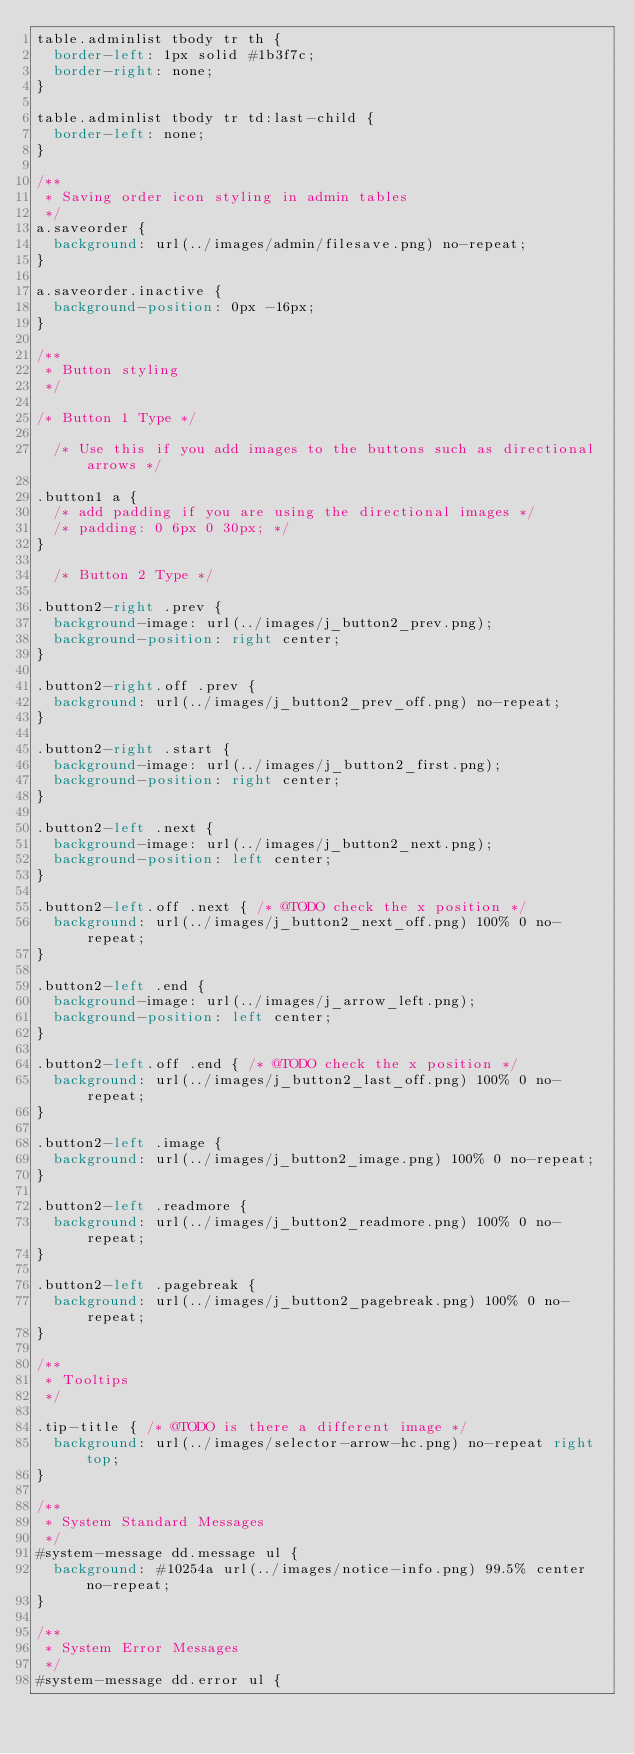Convert code to text. <code><loc_0><loc_0><loc_500><loc_500><_CSS_>table.adminlist tbody tr th {
	border-left: 1px solid #1b3f7c;
	border-right: none;
}

table.adminlist tbody tr td:last-child {
	border-left: none;
}

/**
 * Saving order icon styling in admin tables
 */
a.saveorder {
	background: url(../images/admin/filesave.png) no-repeat;
}

a.saveorder.inactive {
	background-position: 0px -16px;
}

/**
 * Button styling
 */

/* Button 1 Type */

	/* Use this if you add images to the buttons such as directional arrows */

.button1 a {
	/* add padding if you are using the directional images */
	/* padding: 0 6px 0 30px; */
}

	/* Button 2 Type */

.button2-right .prev {
	background-image: url(../images/j_button2_prev.png);
	background-position: right center;
}

.button2-right.off .prev {
	background: url(../images/j_button2_prev_off.png) no-repeat;
}

.button2-right .start {
	background-image: url(../images/j_button2_first.png);
	background-position: right center;
}

.button2-left .next {
	background-image: url(../images/j_button2_next.png);
	background-position: left center;
}

.button2-left.off .next { /* @TODO check the x position */
	background: url(../images/j_button2_next_off.png) 100% 0 no-repeat;
}

.button2-left .end {
	background-image: url(../images/j_arrow_left.png);
	background-position: left center;
}

.button2-left.off .end { /* @TODO check the x position */
	background: url(../images/j_button2_last_off.png) 100% 0 no-repeat;
}

.button2-left .image {
	background: url(../images/j_button2_image.png) 100% 0 no-repeat;
}

.button2-left .readmore {
	background: url(../images/j_button2_readmore.png) 100% 0 no-repeat;
}

.button2-left .pagebreak {
	background: url(../images/j_button2_pagebreak.png) 100% 0 no-repeat;
}

/**
 * Tooltips
 */

.tip-title { /* @TODO is there a different image */
	background: url(../images/selector-arrow-hc.png) no-repeat right top;
}

/**
 * System Standard Messages
 */
#system-message dd.message ul {
	background: #10254a url(../images/notice-info.png) 99.5% center no-repeat;
}

/**
 * System Error Messages
 */
#system-message dd.error ul {</code> 